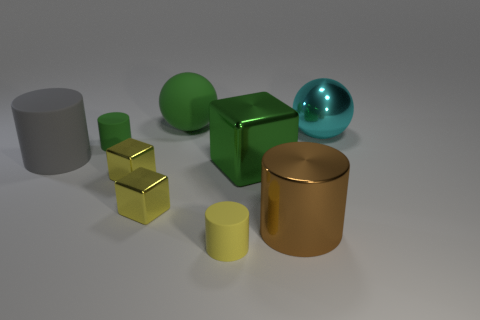Add 1 tiny green cylinders. How many objects exist? 10 Subtract all cylinders. How many objects are left? 5 Add 6 metal cylinders. How many metal cylinders are left? 7 Add 7 yellow metallic balls. How many yellow metallic balls exist? 7 Subtract 1 cyan spheres. How many objects are left? 8 Subtract all small yellow rubber objects. Subtract all cylinders. How many objects are left? 4 